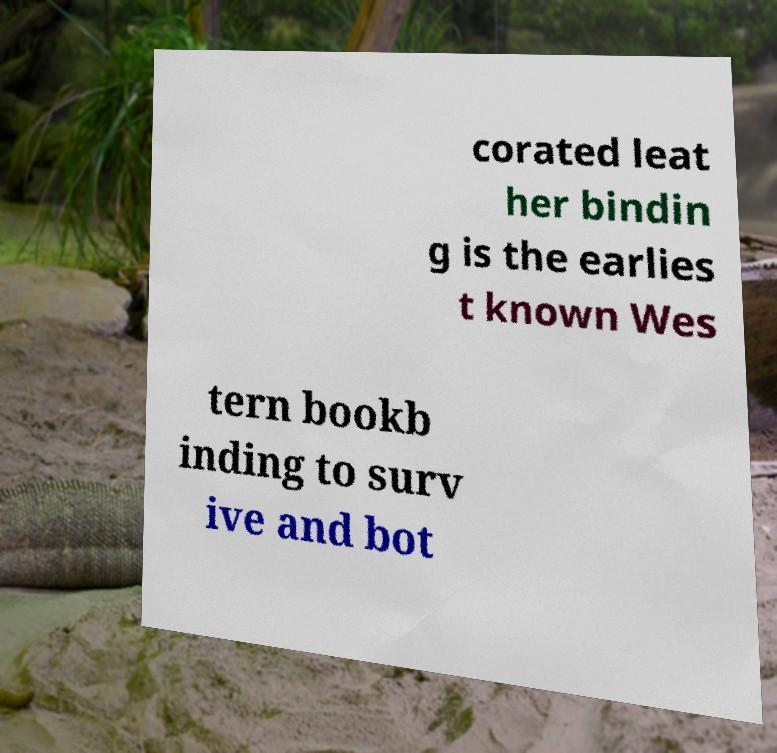For documentation purposes, I need the text within this image transcribed. Could you provide that? corated leat her bindin g is the earlies t known Wes tern bookb inding to surv ive and bot 